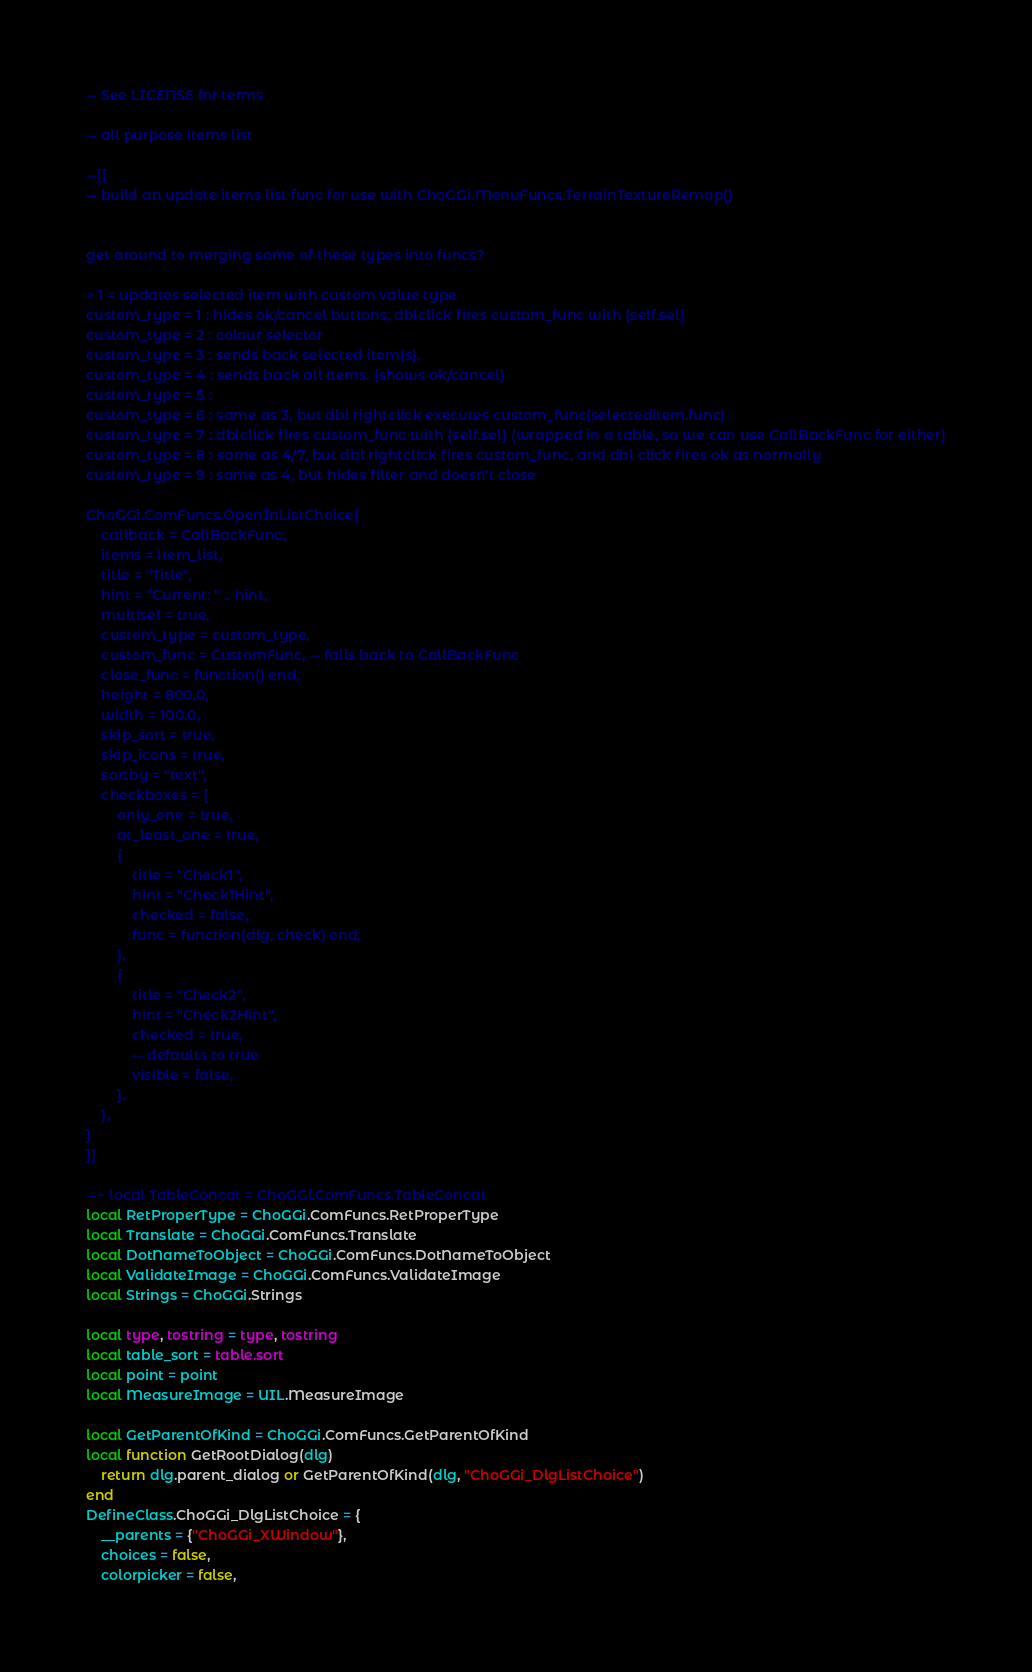<code> <loc_0><loc_0><loc_500><loc_500><_Lua_>-- See LICENSE for terms

-- all purpose items list

--[[
-- build an update items list func for use with ChoGGi.MenuFuncs.TerrainTextureRemap()


get around to merging some of these types into funcs?

> 1 = updates selected item with custom value type
custom_type = 1 : hides ok/cancel buttons, dblclick fires custom_func with {self.sel}
custom_type = 2 : colour selector
custom_type = 3 : sends back selected item(s).
custom_type = 4 : sends back all items. (shows ok/cancel)
custom_type = 5 :
custom_type = 6 : same as 3, but dbl rightclick executes custom_func(selecteditem.func)
custom_type = 7 : dblclick fires custom_func with {self.sel} (wrapped in a table, so we can use CallBackFunc for either)
custom_type = 8 : same as 4/7, but dbl rightclick fires custom_func, and dbl click fires ok as normally
custom_type = 9 : same as 4, but hides filter and doesn't close

ChoGGi.ComFuncs.OpenInListChoice{
	callback = CallBackFunc,
	items = item_list,
	title = "Title",
	hint = "Current: " .. hint,
	multisel = true,
	custom_type = custom_type,
	custom_func = CustomFunc, -- falls back to CallBackFunc
	close_func = function() end,
	height = 800.0,
	width = 100.0,
	skip_sort = true,
	skip_icons = true,
	sortby = "text",
	checkboxes = {
		only_one = true,
		at_least_one = true,
		{
			title = "Check1",
			hint = "Check1Hint",
			checked = false,
			func = function(dlg, check) end,
		},
		{
			title = "Check2",
			hint = "Check2Hint",
			checked = true,
			-- defaults to true
			visible = false,
		},
	},
}
]]

--~ local TableConcat = ChoGGi.ComFuncs.TableConcat
local RetProperType = ChoGGi.ComFuncs.RetProperType
local Translate = ChoGGi.ComFuncs.Translate
local DotNameToObject = ChoGGi.ComFuncs.DotNameToObject
local ValidateImage = ChoGGi.ComFuncs.ValidateImage
local Strings = ChoGGi.Strings

local type, tostring = type, tostring
local table_sort = table.sort
local point = point
local MeasureImage = UIL.MeasureImage

local GetParentOfKind = ChoGGi.ComFuncs.GetParentOfKind
local function GetRootDialog(dlg)
	return dlg.parent_dialog or GetParentOfKind(dlg, "ChoGGi_DlgListChoice")
end
DefineClass.ChoGGi_DlgListChoice = {
	__parents = {"ChoGGi_XWindow"},
	choices = false,
	colorpicker = false,</code> 